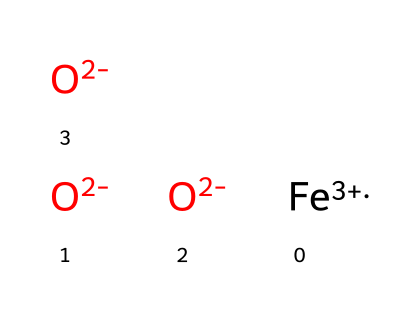what is the oxidation state of iron in this structure? In the provided SMILES, the presence of [Fe+3] indicates that the iron (Fe) has an oxidation state of +3.
Answer: +3 how many oxygen atoms are in the chemical structure? The representation shows three [O-2] symbols, indicating three oxygen atoms in total.
Answer: 3 what type of ions are present in this chemical? The structure contains both cations and anions: [Fe+3] is a cation and [O-2] represents anions, demonstrating that it includes both types.
Answer: cations and anions which element in this structure is likely responsible for the pigmentation in wood stains? The presence of iron ions (Fe) is commonly associated with pigmentation in various dye applications, including wood stains, suggesting it is responsible for color.
Answer: iron does the presence of negatively charged oxygen suggest any property of this dye? The negatively charged oxygen (O-2) suggests that the compound is likely to react with positively charged metal ions, impacting its function as a dye in creating stable colorations.
Answer: reactivity what is the total net charge of the entire structure? With one Fe at +3 and three O at -2 each, calculating the total: +3 + (3 * -2) = +3 - 6 = -3, showing that the net charge is -3.
Answer: -3 